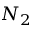<formula> <loc_0><loc_0><loc_500><loc_500>N _ { 2 }</formula> 